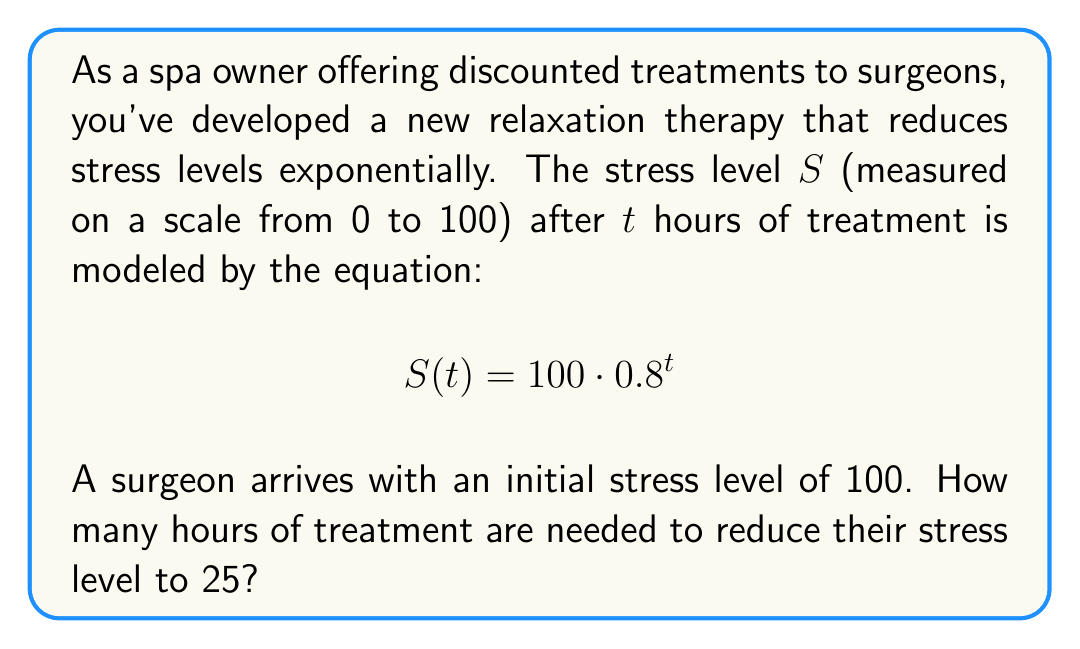Provide a solution to this math problem. To solve this problem, we need to use logarithms. Let's approach this step-by-step:

1) We start with the equation: $S(t) = 100 \cdot 0.8^t$

2) We want to find $t$ when $S(t) = 25$. So, let's substitute this:

   $25 = 100 \cdot 0.8^t$

3) Divide both sides by 100:

   $0.25 = 0.8^t$

4) Now, we can apply logarithms to both sides. Let's use the natural logarithm (ln):

   $\ln(0.25) = \ln(0.8^t)$

5) Using the logarithm property $\ln(a^b) = b\ln(a)$, we get:

   $\ln(0.25) = t \cdot \ln(0.8)$

6) Now we can solve for $t$:

   $t = \frac{\ln(0.25)}{\ln(0.8)}$

7) Using a calculator or computer:

   $t \approx 6.7301$ hours

Therefore, approximately 6.73 hours of treatment are needed to reduce the surgeon's stress level to 25.
Answer: $t \approx 6.73$ hours 